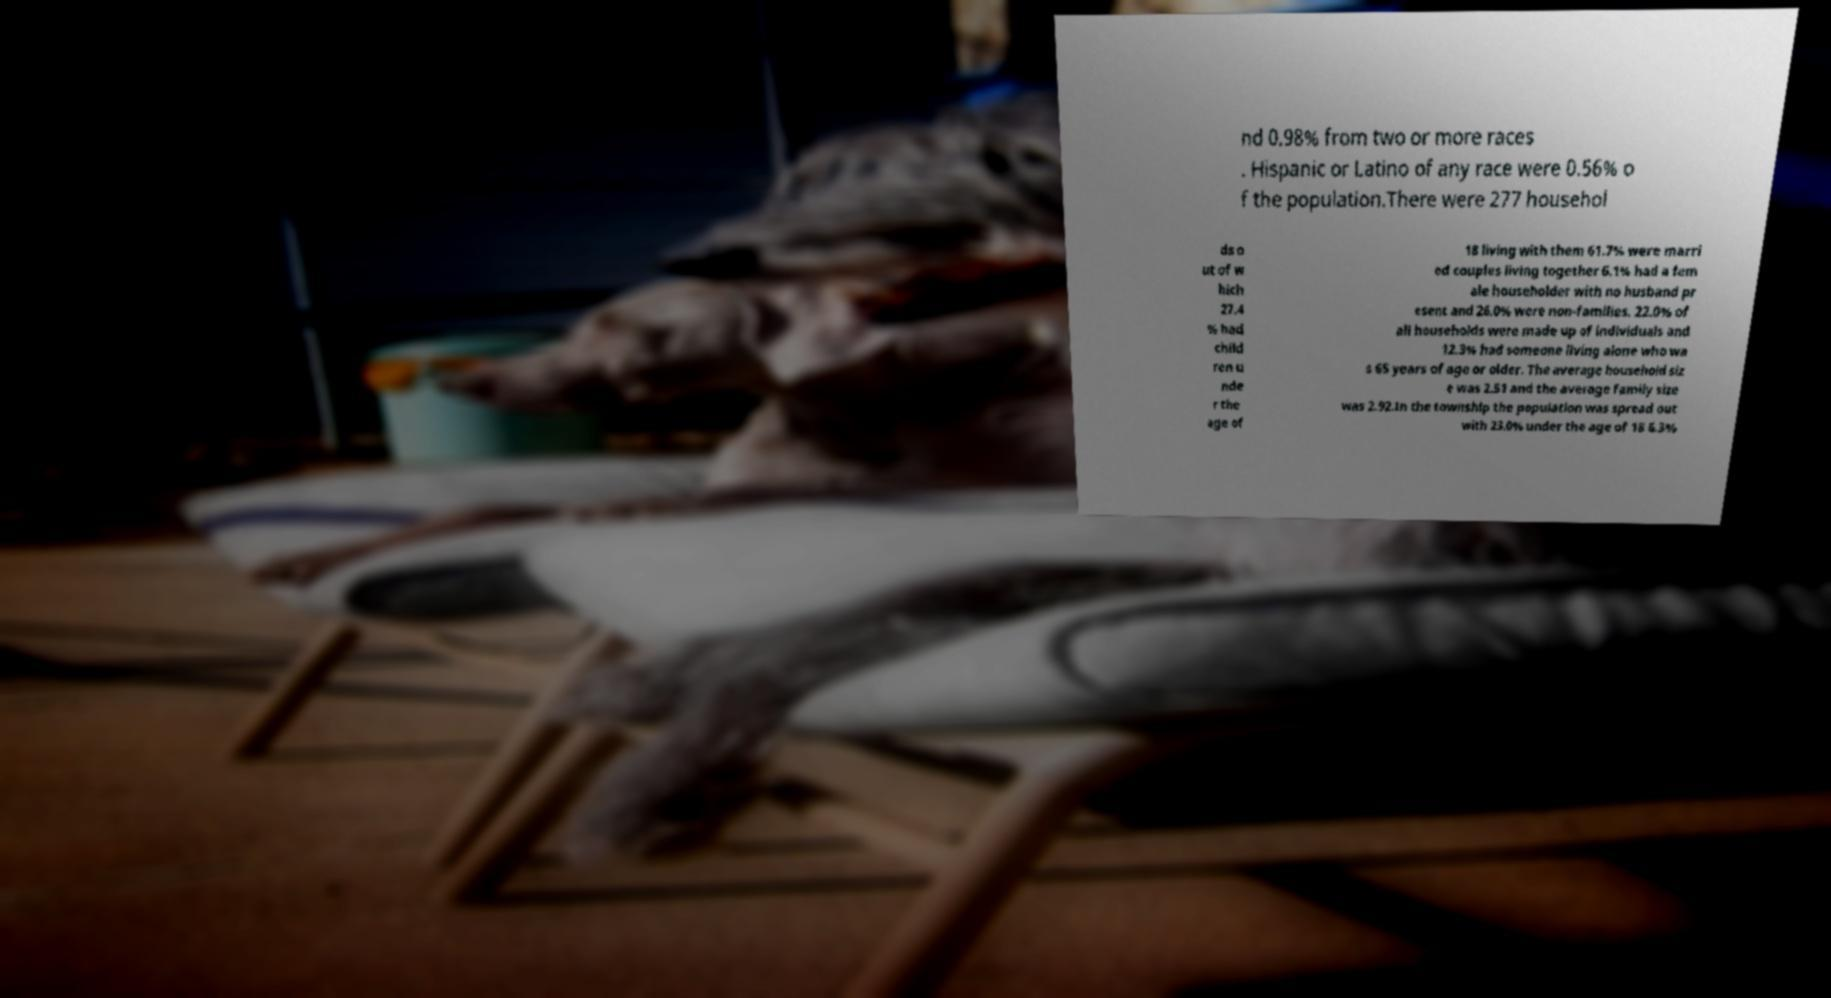Could you extract and type out the text from this image? nd 0.98% from two or more races . Hispanic or Latino of any race were 0.56% o f the population.There were 277 househol ds o ut of w hich 27.4 % had child ren u nde r the age of 18 living with them 61.7% were marri ed couples living together 6.1% had a fem ale householder with no husband pr esent and 26.0% were non-families. 22.0% of all households were made up of individuals and 12.3% had someone living alone who wa s 65 years of age or older. The average household siz e was 2.51 and the average family size was 2.92.In the township the population was spread out with 23.0% under the age of 18 6.3% 